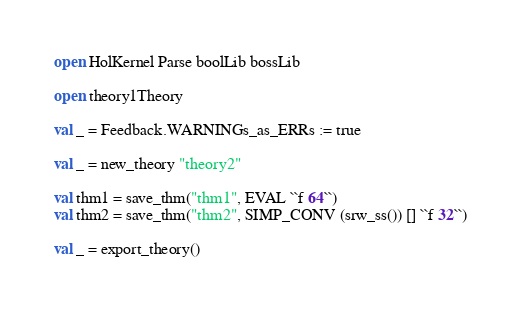<code> <loc_0><loc_0><loc_500><loc_500><_SML_>open HolKernel Parse boolLib bossLib

open theory1Theory

val _ = Feedback.WARNINGs_as_ERRs := true

val _ = new_theory "theory2"

val thm1 = save_thm("thm1", EVAL ``f 64``)
val thm2 = save_thm("thm2", SIMP_CONV (srw_ss()) [] ``f 32``)

val _ = export_theory()
</code> 